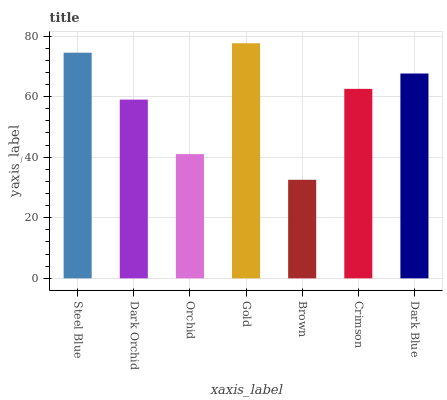Is Dark Orchid the minimum?
Answer yes or no. No. Is Dark Orchid the maximum?
Answer yes or no. No. Is Steel Blue greater than Dark Orchid?
Answer yes or no. Yes. Is Dark Orchid less than Steel Blue?
Answer yes or no. Yes. Is Dark Orchid greater than Steel Blue?
Answer yes or no. No. Is Steel Blue less than Dark Orchid?
Answer yes or no. No. Is Crimson the high median?
Answer yes or no. Yes. Is Crimson the low median?
Answer yes or no. Yes. Is Steel Blue the high median?
Answer yes or no. No. Is Dark Orchid the low median?
Answer yes or no. No. 